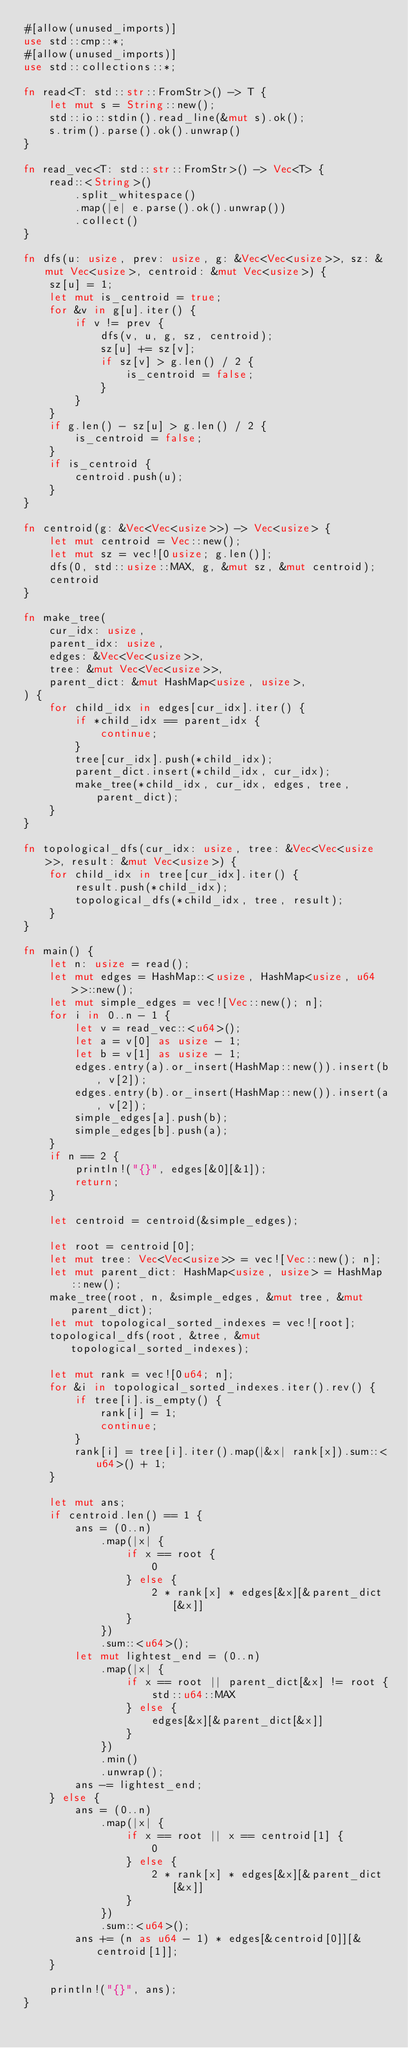<code> <loc_0><loc_0><loc_500><loc_500><_Rust_>#[allow(unused_imports)]
use std::cmp::*;
#[allow(unused_imports)]
use std::collections::*;

fn read<T: std::str::FromStr>() -> T {
    let mut s = String::new();
    std::io::stdin().read_line(&mut s).ok();
    s.trim().parse().ok().unwrap()
}

fn read_vec<T: std::str::FromStr>() -> Vec<T> {
    read::<String>()
        .split_whitespace()
        .map(|e| e.parse().ok().unwrap())
        .collect()
}

fn dfs(u: usize, prev: usize, g: &Vec<Vec<usize>>, sz: &mut Vec<usize>, centroid: &mut Vec<usize>) {
    sz[u] = 1;
    let mut is_centroid = true;
    for &v in g[u].iter() {
        if v != prev {
            dfs(v, u, g, sz, centroid);
            sz[u] += sz[v];
            if sz[v] > g.len() / 2 {
                is_centroid = false;
            }
        }
    }
    if g.len() - sz[u] > g.len() / 2 {
        is_centroid = false;
    }
    if is_centroid {
        centroid.push(u);
    }
}

fn centroid(g: &Vec<Vec<usize>>) -> Vec<usize> {
    let mut centroid = Vec::new();
    let mut sz = vec![0usize; g.len()];
    dfs(0, std::usize::MAX, g, &mut sz, &mut centroid);
    centroid
}

fn make_tree(
    cur_idx: usize,
    parent_idx: usize,
    edges: &Vec<Vec<usize>>,
    tree: &mut Vec<Vec<usize>>,
    parent_dict: &mut HashMap<usize, usize>,
) {
    for child_idx in edges[cur_idx].iter() {
        if *child_idx == parent_idx {
            continue;
        }
        tree[cur_idx].push(*child_idx);
        parent_dict.insert(*child_idx, cur_idx);
        make_tree(*child_idx, cur_idx, edges, tree, parent_dict);
    }
}

fn topological_dfs(cur_idx: usize, tree: &Vec<Vec<usize>>, result: &mut Vec<usize>) {
    for child_idx in tree[cur_idx].iter() {
        result.push(*child_idx);
        topological_dfs(*child_idx, tree, result);
    }
}

fn main() {
    let n: usize = read();
    let mut edges = HashMap::<usize, HashMap<usize, u64>>::new();
    let mut simple_edges = vec![Vec::new(); n];
    for i in 0..n - 1 {
        let v = read_vec::<u64>();
        let a = v[0] as usize - 1;
        let b = v[1] as usize - 1;
        edges.entry(a).or_insert(HashMap::new()).insert(b, v[2]);
        edges.entry(b).or_insert(HashMap::new()).insert(a, v[2]);
        simple_edges[a].push(b);
        simple_edges[b].push(a);
    }
    if n == 2 {
        println!("{}", edges[&0][&1]);
        return;
    }

    let centroid = centroid(&simple_edges);

    let root = centroid[0];
    let mut tree: Vec<Vec<usize>> = vec![Vec::new(); n];
    let mut parent_dict: HashMap<usize, usize> = HashMap::new();
    make_tree(root, n, &simple_edges, &mut tree, &mut parent_dict);
    let mut topological_sorted_indexes = vec![root];
    topological_dfs(root, &tree, &mut topological_sorted_indexes);

    let mut rank = vec![0u64; n];
    for &i in topological_sorted_indexes.iter().rev() {
        if tree[i].is_empty() {
            rank[i] = 1;
            continue;
        }
        rank[i] = tree[i].iter().map(|&x| rank[x]).sum::<u64>() + 1;
    }

    let mut ans;
    if centroid.len() == 1 {
        ans = (0..n)
            .map(|x| {
                if x == root {
                    0
                } else {
                    2 * rank[x] * edges[&x][&parent_dict[&x]]
                }
            })
            .sum::<u64>();
        let mut lightest_end = (0..n)
            .map(|x| {
                if x == root || parent_dict[&x] != root {
                    std::u64::MAX
                } else {
                    edges[&x][&parent_dict[&x]]
                }
            })
            .min()
            .unwrap();
        ans -= lightest_end;
    } else {
        ans = (0..n)
            .map(|x| {
                if x == root || x == centroid[1] {
                    0
                } else {
                    2 * rank[x] * edges[&x][&parent_dict[&x]]
                }
            })
            .sum::<u64>();
        ans += (n as u64 - 1) * edges[&centroid[0]][&centroid[1]];
    }

    println!("{}", ans);
}
</code> 